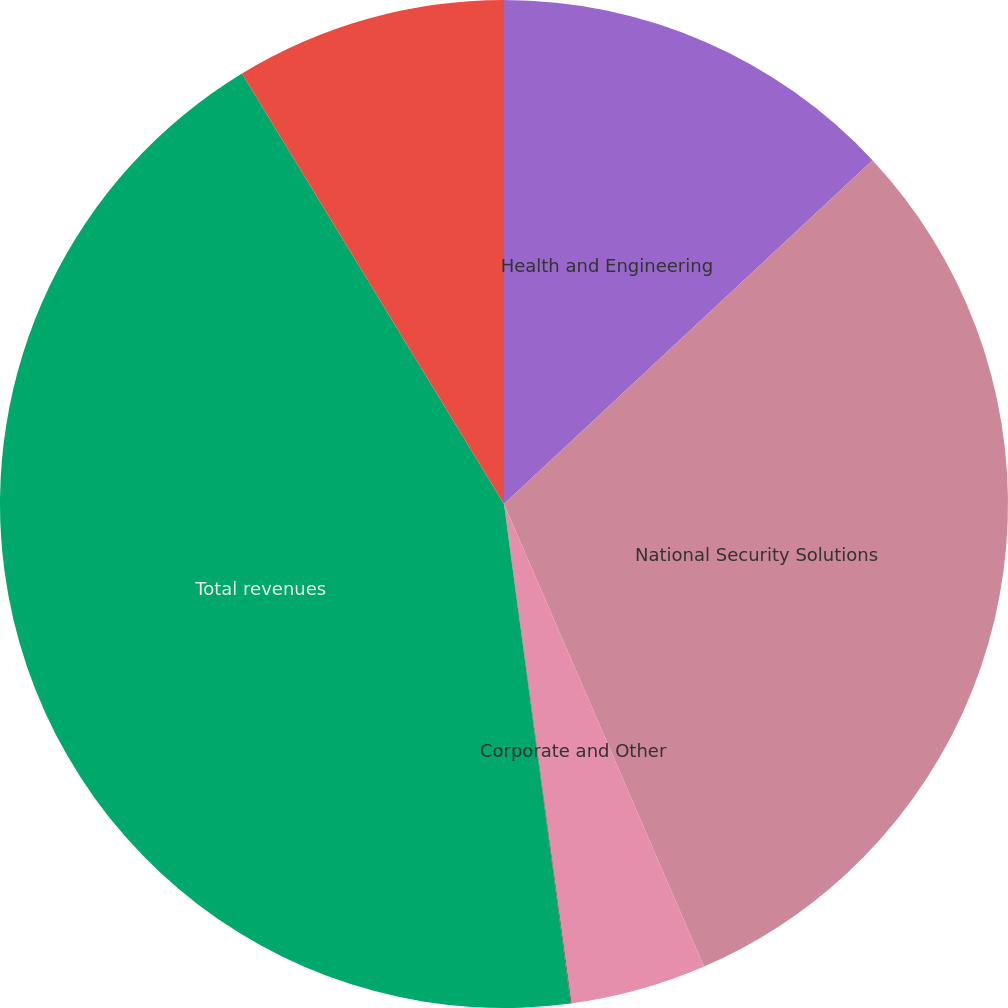<chart> <loc_0><loc_0><loc_500><loc_500><pie_chart><fcel>Health and Engineering<fcel>National Security Solutions<fcel>Corporate and Other<fcel>Intersegment elimination<fcel>Total revenues<fcel>Total operating income (loss)<nl><fcel>13.05%<fcel>30.45%<fcel>4.36%<fcel>0.02%<fcel>43.41%<fcel>8.7%<nl></chart> 